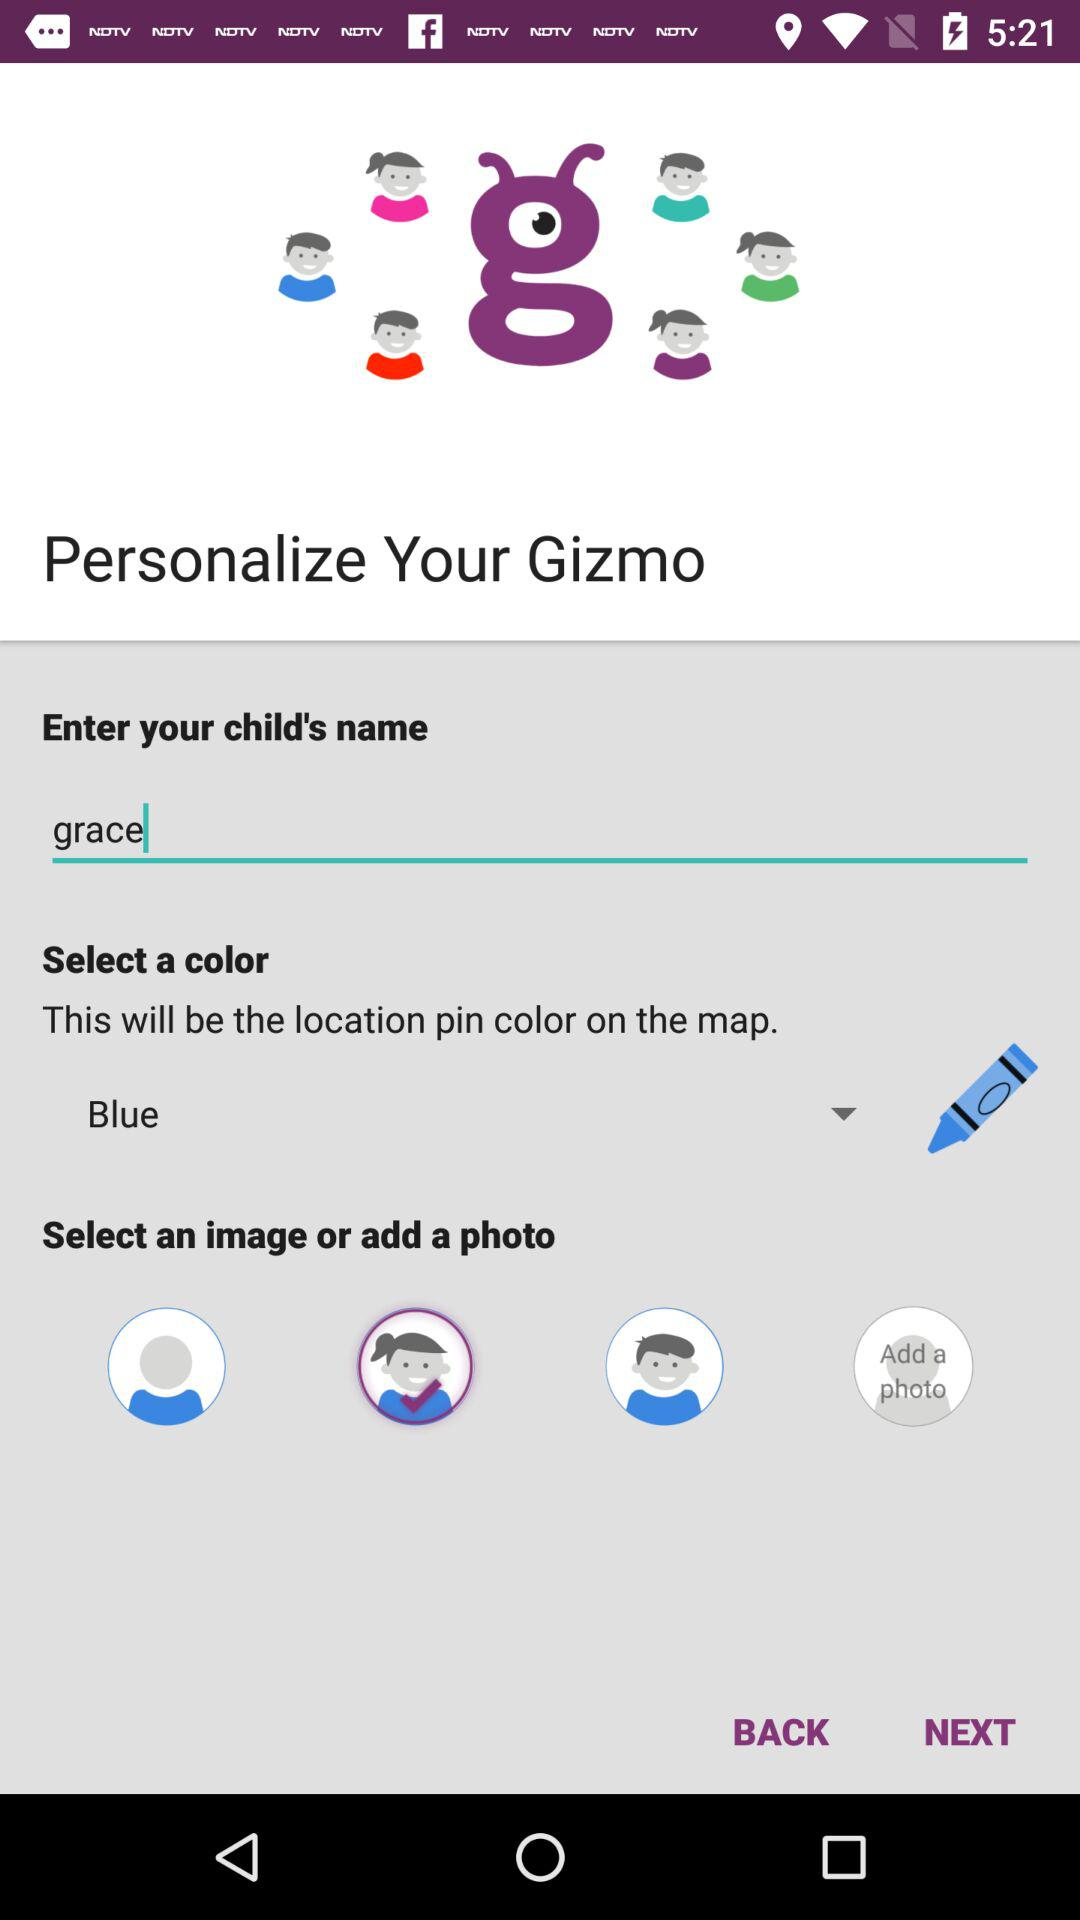What's the child name? The child name is Grace. 